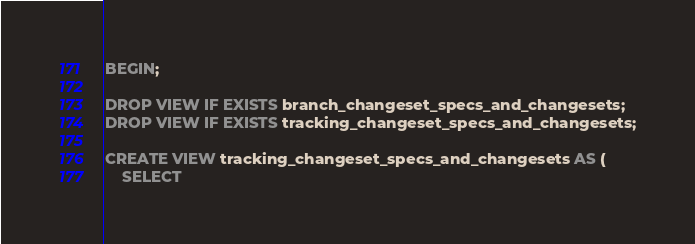Convert code to text. <code><loc_0><loc_0><loc_500><loc_500><_SQL_>BEGIN;

DROP VIEW IF EXISTS branch_changeset_specs_and_changesets;
DROP VIEW IF EXISTS tracking_changeset_specs_and_changesets;

CREATE VIEW tracking_changeset_specs_and_changesets AS (
    SELECT</code> 